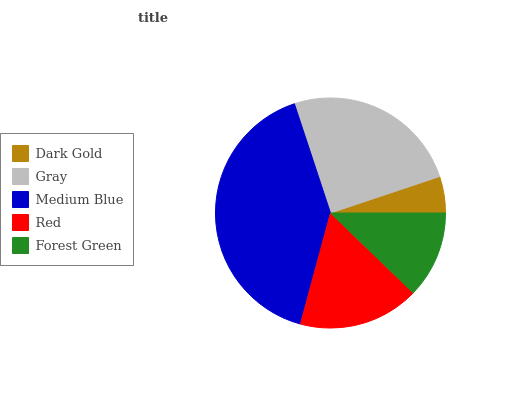Is Dark Gold the minimum?
Answer yes or no. Yes. Is Medium Blue the maximum?
Answer yes or no. Yes. Is Gray the minimum?
Answer yes or no. No. Is Gray the maximum?
Answer yes or no. No. Is Gray greater than Dark Gold?
Answer yes or no. Yes. Is Dark Gold less than Gray?
Answer yes or no. Yes. Is Dark Gold greater than Gray?
Answer yes or no. No. Is Gray less than Dark Gold?
Answer yes or no. No. Is Red the high median?
Answer yes or no. Yes. Is Red the low median?
Answer yes or no. Yes. Is Dark Gold the high median?
Answer yes or no. No. Is Dark Gold the low median?
Answer yes or no. No. 